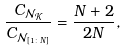<formula> <loc_0><loc_0><loc_500><loc_500>\frac { C _ { \mathcal { N } _ { \mathcal { K } } } } { { C } _ { \mathcal { N } _ { [ 1 \colon N ] } } } = \frac { N + 2 } { 2 N } ,</formula> 